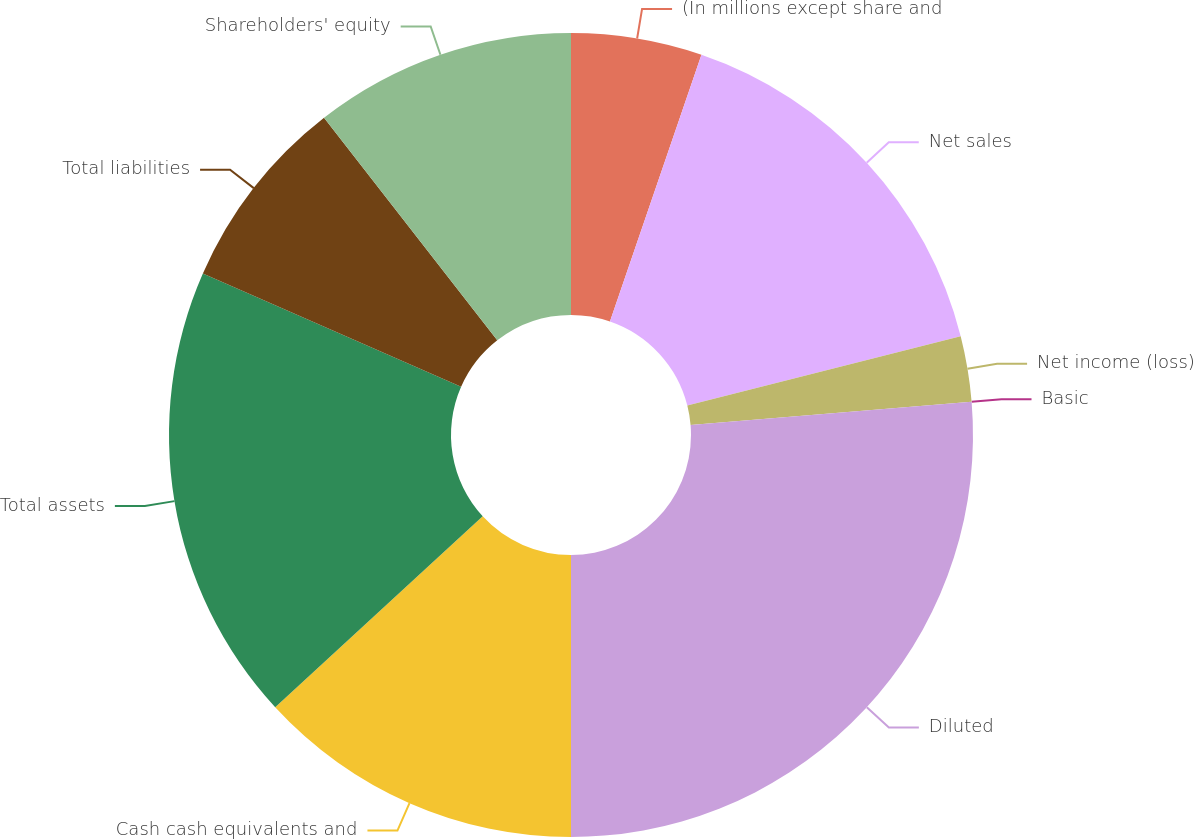Convert chart to OTSL. <chart><loc_0><loc_0><loc_500><loc_500><pie_chart><fcel>(In millions except share and<fcel>Net sales<fcel>Net income (loss)<fcel>Basic<fcel>Diluted<fcel>Cash cash equivalents and<fcel>Total assets<fcel>Total liabilities<fcel>Shareholders' equity<nl><fcel>5.26%<fcel>15.79%<fcel>2.63%<fcel>0.0%<fcel>26.32%<fcel>13.16%<fcel>18.42%<fcel>7.89%<fcel>10.53%<nl></chart> 